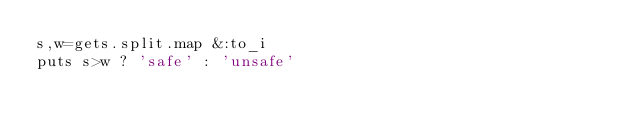<code> <loc_0><loc_0><loc_500><loc_500><_Ruby_>s,w=gets.split.map &:to_i
puts s>w ? 'safe' : 'unsafe'</code> 